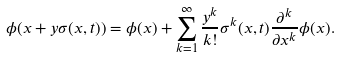<formula> <loc_0><loc_0><loc_500><loc_500>\phi ( x + y \sigma ( x , t ) ) = \phi ( x ) + \sum _ { k = 1 } ^ { \infty } \frac { y ^ { k } } { k ! } \sigma ^ { k } ( x , t ) \frac { \partial ^ { k } } { \partial x ^ { k } } \phi ( x ) .</formula> 